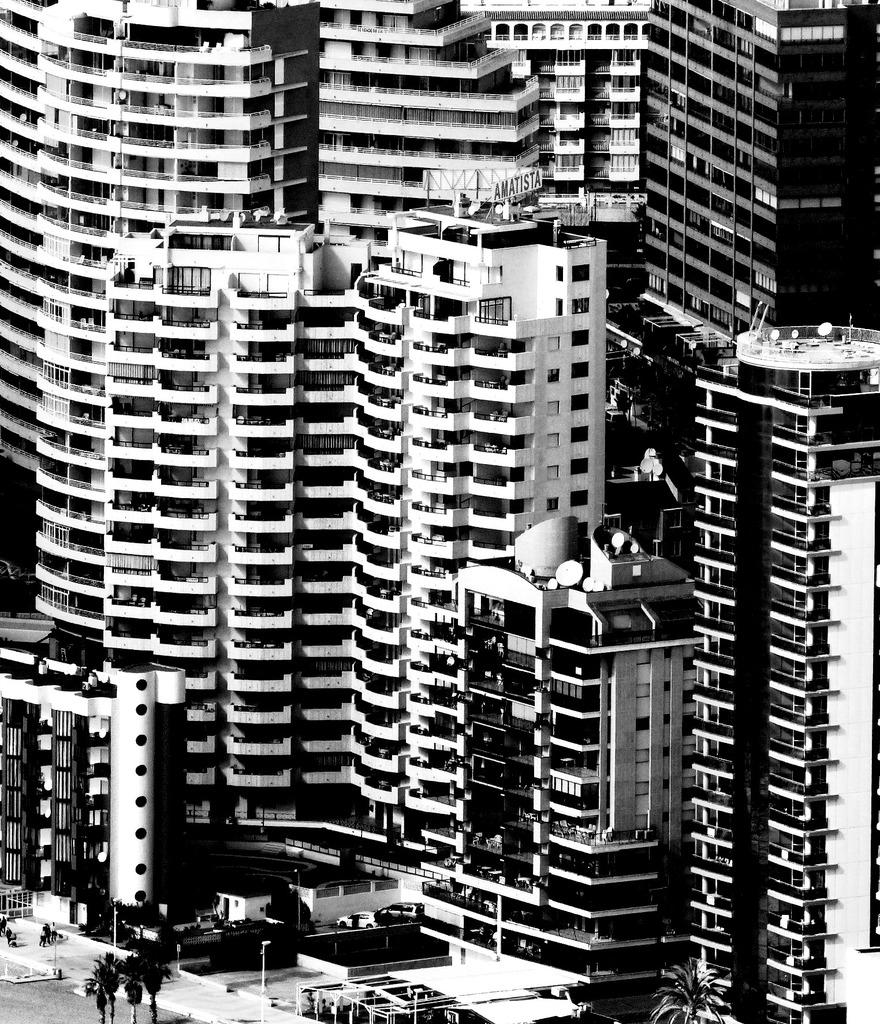What is the color scheme of the image? The image is black and white. What type of natural elements can be seen in the image? There are trees in the image. What type of man-made structures are present in the image? There are buildings in the image. What type of transportation is visible in the image? There are vehicles in the image. What type of vertical structures can be seen in the image? There are poles in the image. What language is spoken by the trees in the image? Trees do not speak any language, so this question cannot be answered. 